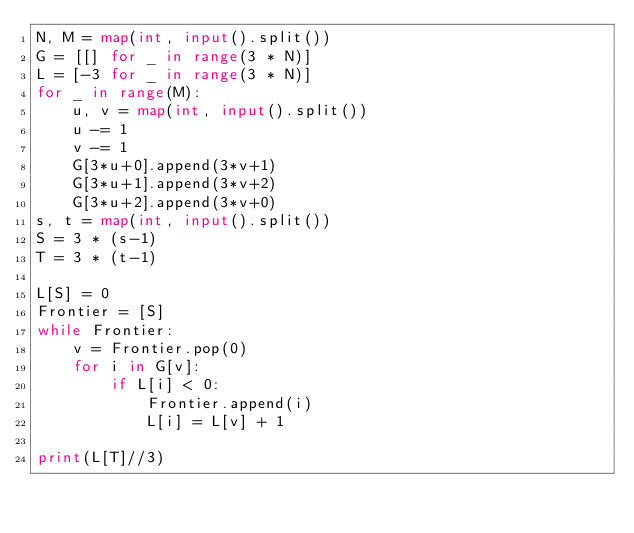Convert code to text. <code><loc_0><loc_0><loc_500><loc_500><_Python_>N, M = map(int, input().split())
G = [[] for _ in range(3 * N)]
L = [-3 for _ in range(3 * N)]
for _ in range(M):
    u, v = map(int, input().split())
    u -= 1
    v -= 1
    G[3*u+0].append(3*v+1)
    G[3*u+1].append(3*v+2)
    G[3*u+2].append(3*v+0)
s, t = map(int, input().split())
S = 3 * (s-1)
T = 3 * (t-1)

L[S] = 0
Frontier = [S]
while Frontier:
    v = Frontier.pop(0)
    for i in G[v]:
        if L[i] < 0:
            Frontier.append(i)
            L[i] = L[v] + 1

print(L[T]//3)</code> 